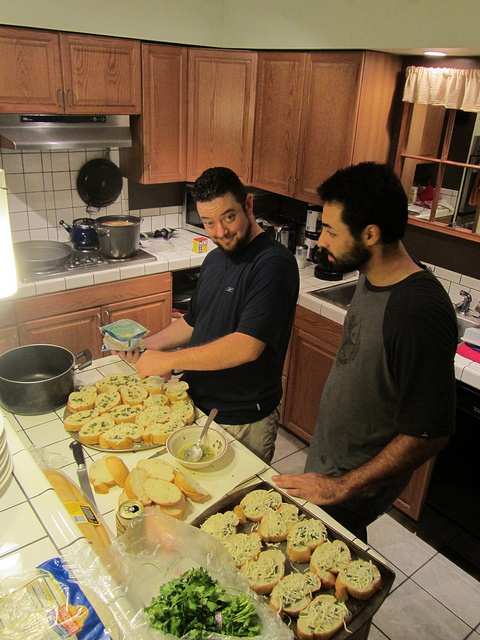Describe the objects in this image and their specific colors. I can see people in tan, black, maroon, and brown tones, people in tan, black, maroon, and brown tones, bowl in tan, olive, and khaki tones, sink in tan, black, and gray tones, and microwave in tan, black, and gray tones in this image. 